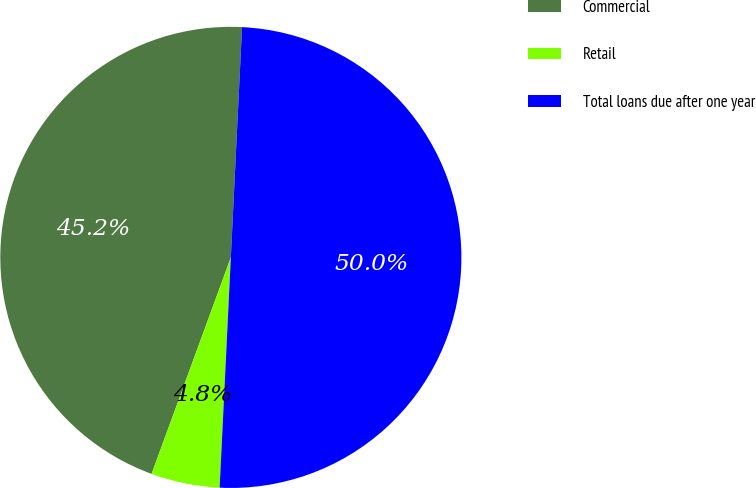<chart> <loc_0><loc_0><loc_500><loc_500><pie_chart><fcel>Commercial<fcel>Retail<fcel>Total loans due after one year<nl><fcel>45.19%<fcel>4.81%<fcel>50.0%<nl></chart> 